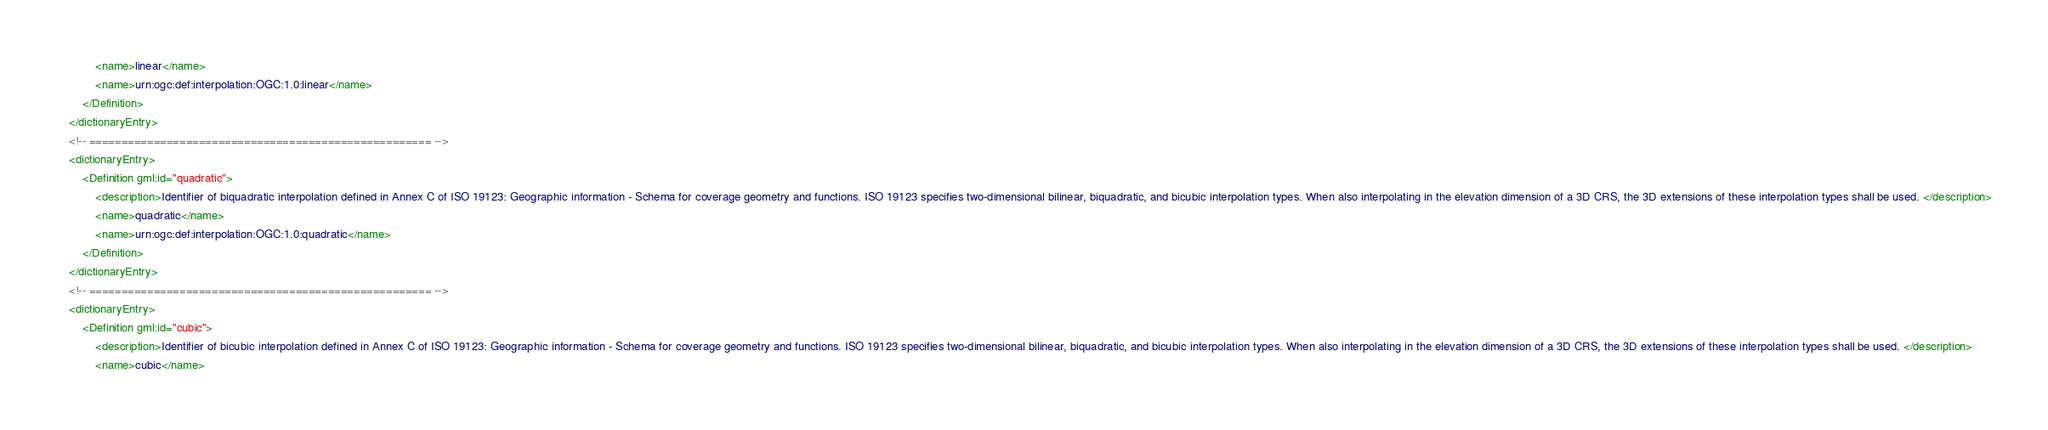<code> <loc_0><loc_0><loc_500><loc_500><_XML_>			<name>linear</name>
			<name>urn:ogc:def:interpolation:OGC:1.0:linear</name>
		</Definition>
	</dictionaryEntry>
	<!-- ===================================================== -->
	<dictionaryEntry>
		<Definition gml:id="quadratic">
			<description>Identifier of biquadratic interpolation defined in Annex C of ISO 19123: Geographic information - Schema for coverage geometry and functions. ISO 19123 specifies two-dimensional bilinear, biquadratic, and bicubic interpolation types. When also interpolating in the elevation dimension of a 3D CRS, the 3D extensions of these interpolation types shall be used. </description>
			<name>quadratic</name>
			<name>urn:ogc:def:interpolation:OGC:1.0:quadratic</name>
		</Definition>
	</dictionaryEntry>
	<!-- ===================================================== -->
	<dictionaryEntry>
		<Definition gml:id="cubic">
			<description>Identifier of bicubic interpolation defined in Annex C of ISO 19123: Geographic information - Schema for coverage geometry and functions. ISO 19123 specifies two-dimensional bilinear, biquadratic, and bicubic interpolation types. When also interpolating in the elevation dimension of a 3D CRS, the 3D extensions of these interpolation types shall be used. </description>
			<name>cubic</name></code> 